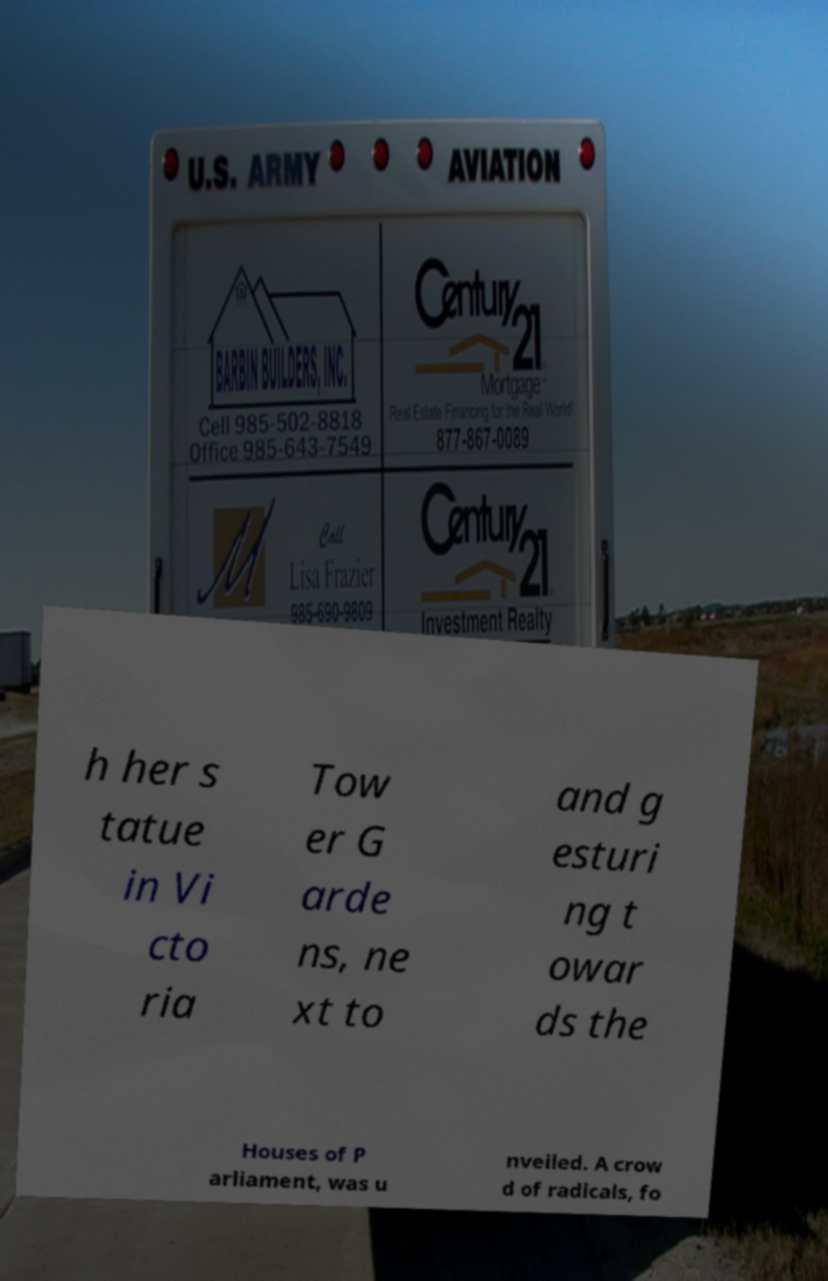Can you read and provide the text displayed in the image?This photo seems to have some interesting text. Can you extract and type it out for me? h her s tatue in Vi cto ria Tow er G arde ns, ne xt to and g esturi ng t owar ds the Houses of P arliament, was u nveiled. A crow d of radicals, fo 